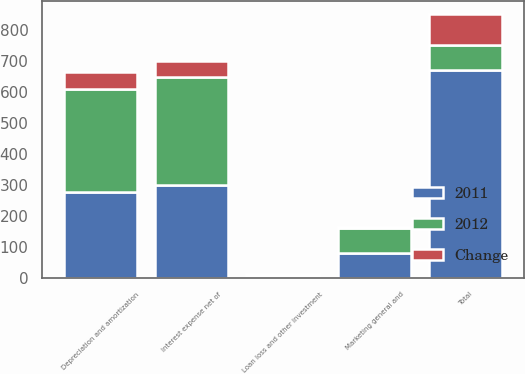<chart> <loc_0><loc_0><loc_500><loc_500><stacked_bar_chart><ecel><fcel>Interest expense net of<fcel>Depreciation and amortization<fcel>Loan loss and other investment<fcel>Marketing general and<fcel>Total<nl><fcel>2012<fcel>350<fcel>332<fcel>0.6<fcel>82.8<fcel>81.45<nl><fcel>2011<fcel>300<fcel>277.3<fcel>6.7<fcel>80.1<fcel>669.7<nl><fcel>Change<fcel>50<fcel>54.7<fcel>6.1<fcel>2.7<fcel>101.3<nl></chart> 